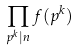Convert formula to latex. <formula><loc_0><loc_0><loc_500><loc_500>\prod _ { p ^ { k } | n } f ( p ^ { k } )</formula> 